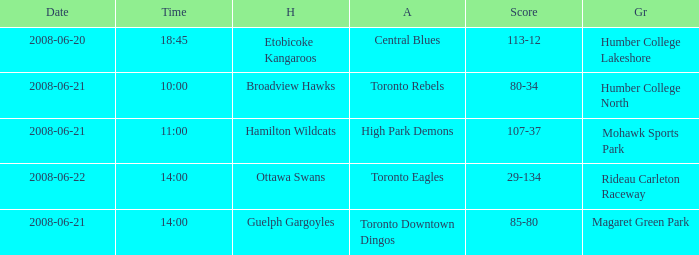What is the Date with a Home that is hamilton wildcats? 2008-06-21. 